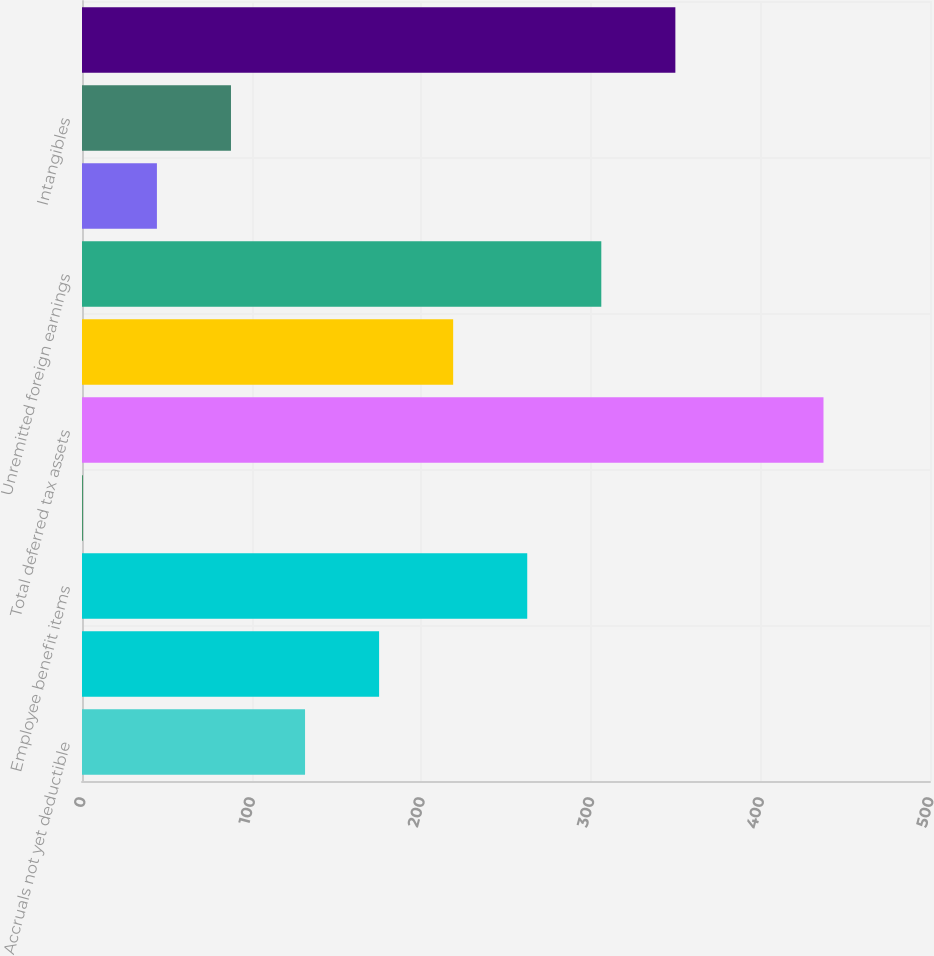<chart> <loc_0><loc_0><loc_500><loc_500><bar_chart><fcel>Accruals not yet deductible<fcel>Foreign net operating loss<fcel>Employee benefit items<fcel>Other<fcel>Total deferred tax assets<fcel>Depreciation and amortization<fcel>Unremitted foreign earnings<fcel>Inventories<fcel>Intangibles<fcel>Total deferred tax liabilities<nl><fcel>131.51<fcel>175.18<fcel>262.52<fcel>0.5<fcel>437.2<fcel>218.85<fcel>306.19<fcel>44.17<fcel>87.84<fcel>349.86<nl></chart> 